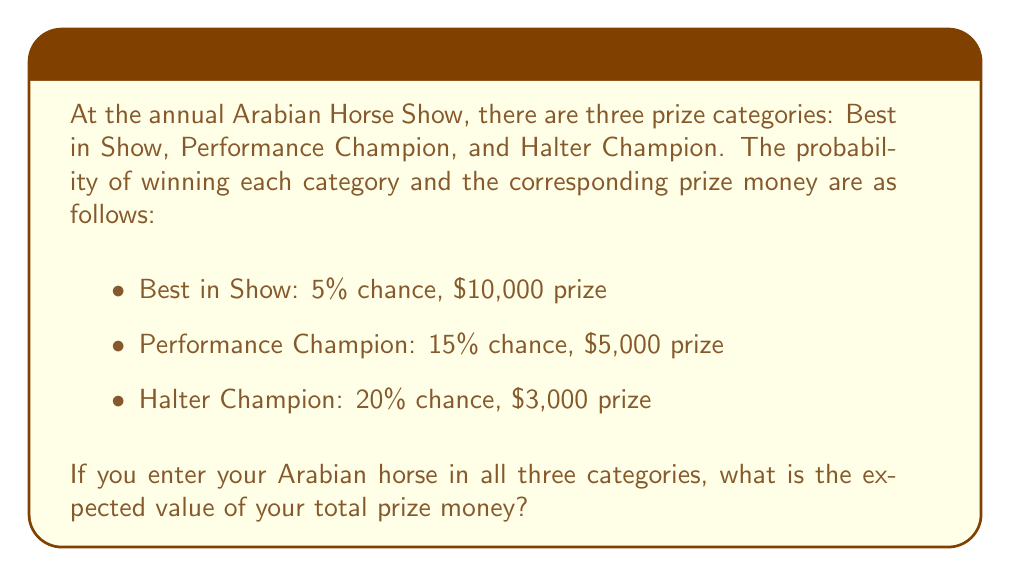Show me your answer to this math problem. To solve this problem, we need to calculate the expected value of the total prize money. The expected value is the sum of each possible outcome multiplied by its probability.

Let's break it down step by step:

1. Calculate the expected value for each category:

   Best in Show: 
   $E(\text{Best in Show}) = 0.05 \times \$10,000 = \$500$

   Performance Champion:
   $E(\text{Performance}) = 0.15 \times \$5,000 = \$750$

   Halter Champion:
   $E(\text{Halter}) = 0.20 \times \$3,000 = \$600$

2. Calculate the probability of not winning in each category:

   Best in Show: $1 - 0.05 = 0.95$
   Performance Champion: $1 - 0.15 = 0.85$
   Halter Champion: $1 - 0.20 = 0.80$

3. Calculate the expected value of the total prize money:

   $E(\text{Total}) = E(\text{Best in Show}) + E(\text{Performance}) + E(\text{Halter})$

   This is because the events are independent, and you can win in multiple categories.

4. Substitute the values:

   $E(\text{Total}) = \$500 + \$750 + \$600 = \$1,850$

Therefore, the expected value of the total prize money is $1,850.
Answer: $1,850 